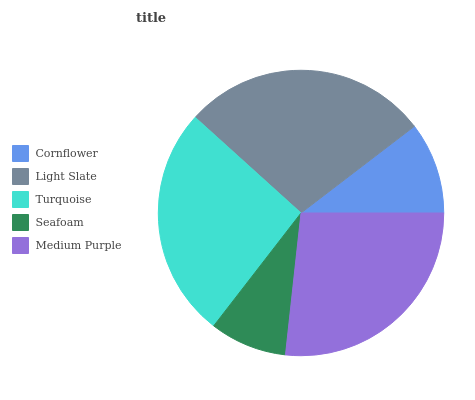Is Seafoam the minimum?
Answer yes or no. Yes. Is Light Slate the maximum?
Answer yes or no. Yes. Is Turquoise the minimum?
Answer yes or no. No. Is Turquoise the maximum?
Answer yes or no. No. Is Light Slate greater than Turquoise?
Answer yes or no. Yes. Is Turquoise less than Light Slate?
Answer yes or no. Yes. Is Turquoise greater than Light Slate?
Answer yes or no. No. Is Light Slate less than Turquoise?
Answer yes or no. No. Is Turquoise the high median?
Answer yes or no. Yes. Is Turquoise the low median?
Answer yes or no. Yes. Is Light Slate the high median?
Answer yes or no. No. Is Seafoam the low median?
Answer yes or no. No. 